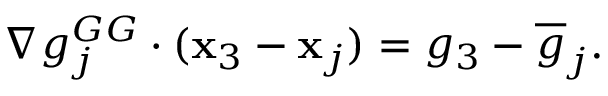Convert formula to latex. <formula><loc_0><loc_0><loc_500><loc_500>\begin{array} { r } { \nabla g _ { j } ^ { G G } \cdot ( { x } _ { 3 } - { x } _ { j } ) = { g } _ { 3 } - \overline { g } _ { j } . } \end{array}</formula> 